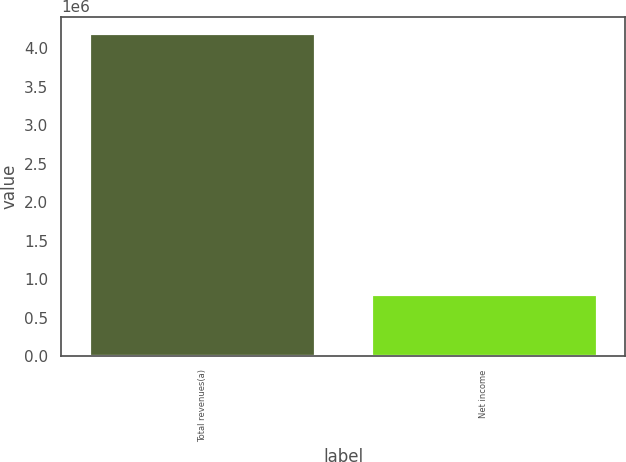<chart> <loc_0><loc_0><loc_500><loc_500><bar_chart><fcel>Total revenues(a)<fcel>Net income<nl><fcel>4.20211e+06<fcel>808696<nl></chart> 